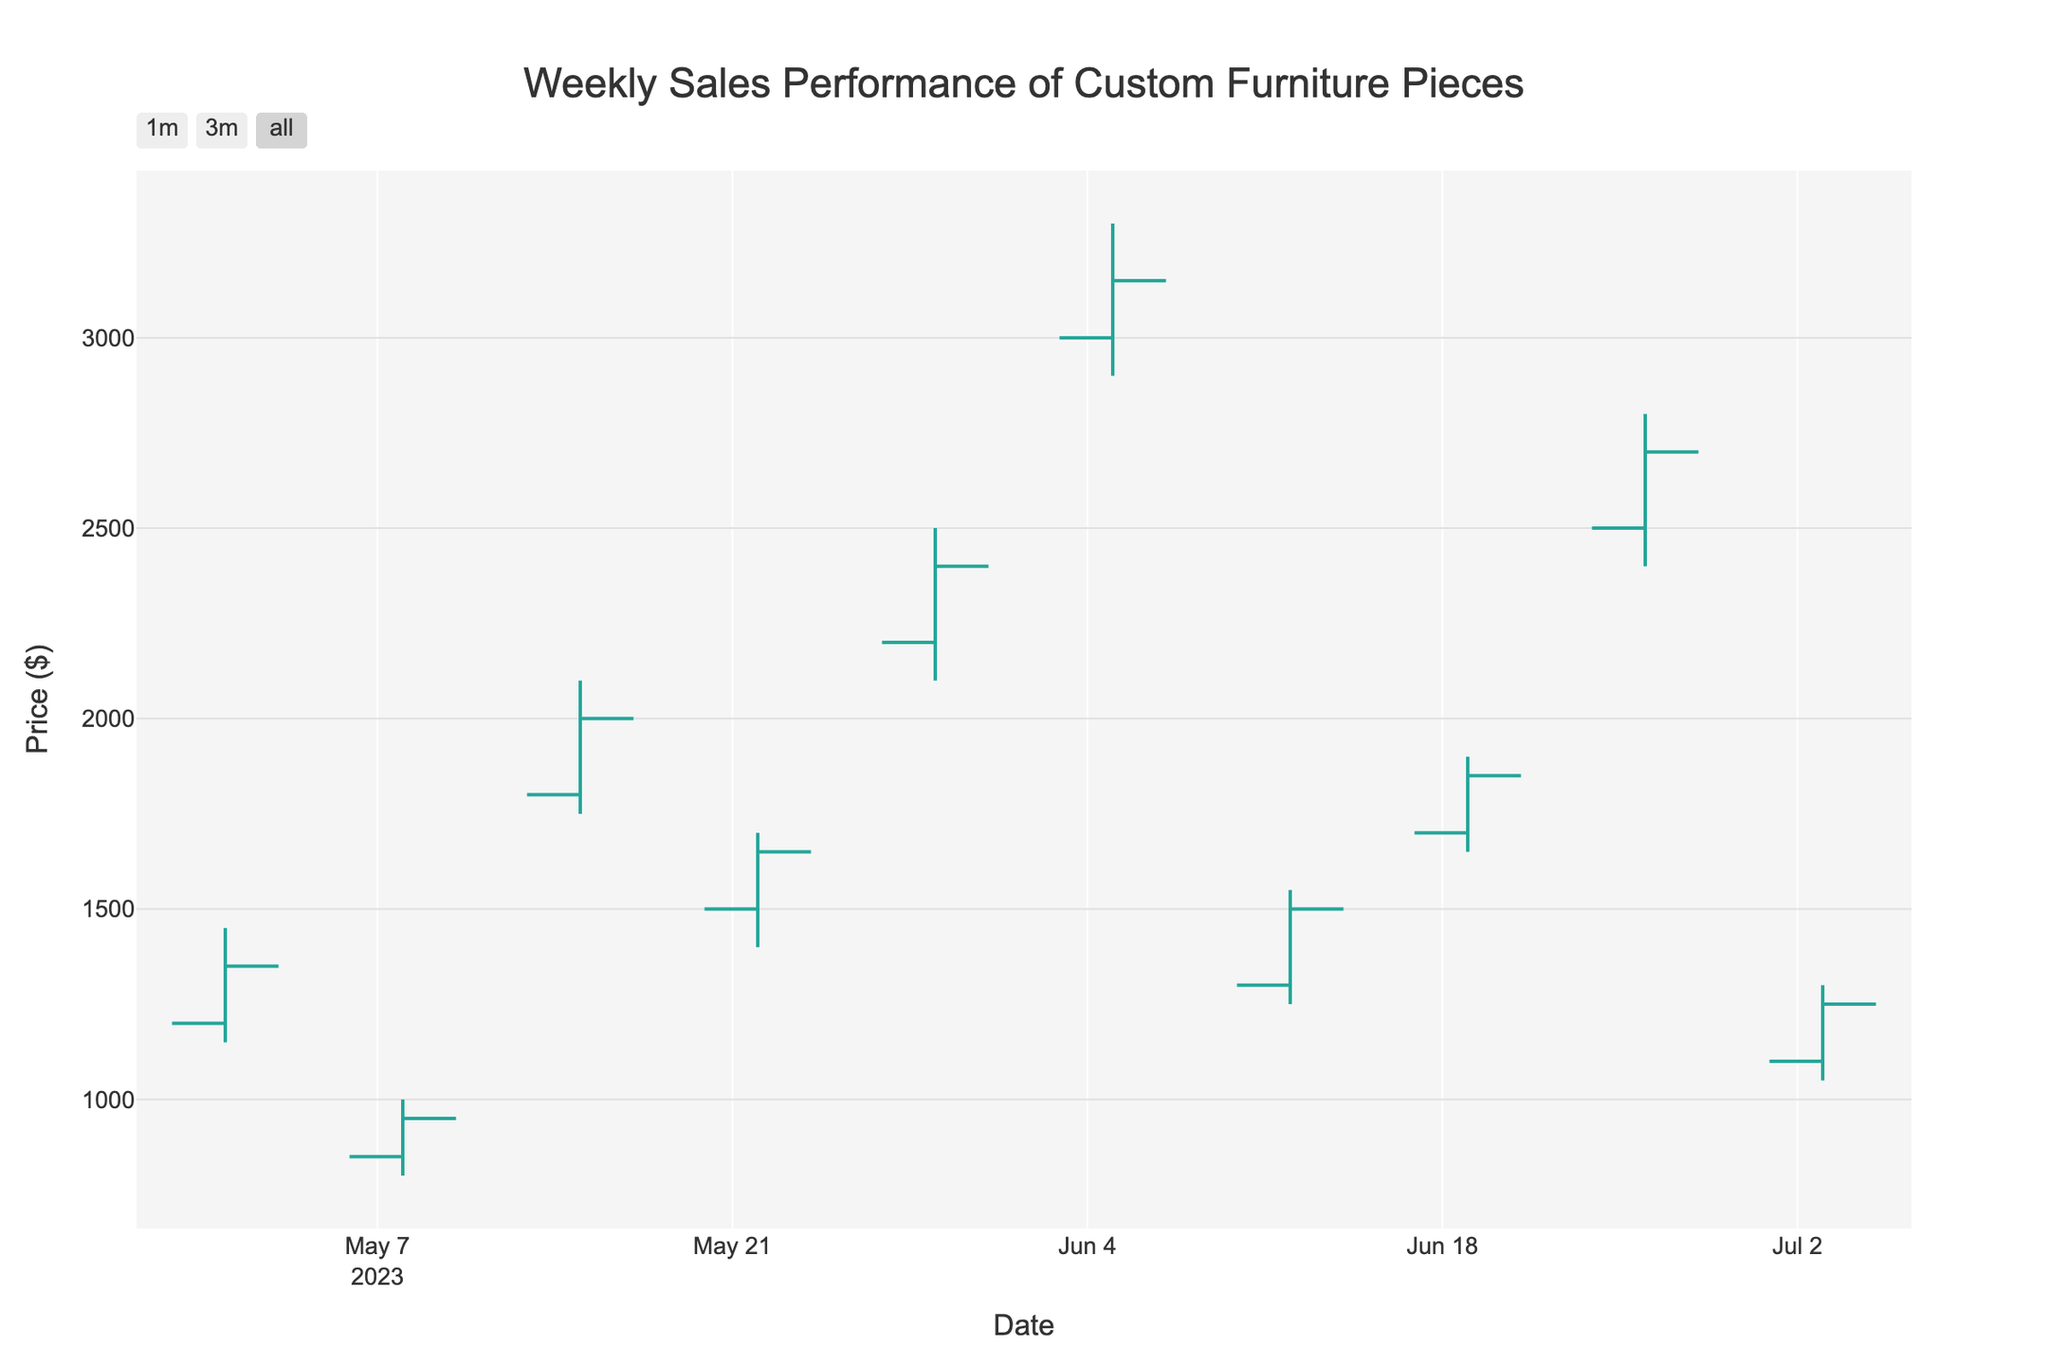what is the title of the chart? The title of the chart is located at the top center of the figure. According to the code, it reads "Weekly Sales Performance of Custom Furniture Pieces".
Answer: Weekly Sales Performance of Custom Furniture Pieces What is the highest price recorded, and which piece did it correspond to? The highest price is represented by the highest point in the 'High' column of the OHLC chart. According to the data provided, the highest price recorded is $3300, and it corresponds to the "French Provincial Dining Set" for the week of 2023-06-05.
Answer: $3300, French Provincial Dining Set How did the Mexican Talavera Tile Table's closing price compare to its opening price? To compare the opening price and closing price for the Mexican Talavera Tile Table, look at the 'Open' and 'Close' values for the week of 2023-07-03. The opening price was $1100 and the closing price was $1250. Since $1250 is greater than $1100, the closing price is higher.
Answer: The closing price is higher Which piece saw the greatest increase in price from its low to high point within a single week, and what was the increase? To find the greatest increase within a single week, subtract the 'Low' value from the 'High' value for each piece and compare. The greatest increase is found by calculating: For "Indian Brass-inlaid Armoire" (2500-2100=400), which is the highest among all pieces.
Answer: Indian Brass-inlaid Armoire, $400 Between May 1st and July 3rd, which piece had the lowest opening price, and how much was it? Compare the 'Open' prices for all pieces within the date range provided. The lowest opening price is $850, which corresponds to the "Moroccan Carved Coffee Table" for the week of 2023-05-08.
Answer: Moroccan Carved Coffee Table, $850 What was the average closing price of all the custom furniture pieces? To find the average closing price, sum the 'Close' values and then divide by the number of pieces (10). Sum: 1350+950+2000+1650+2400+3150+1500+1850+2700+1250 = 17800. Average: 17800 / 10 = 1780.
Answer: $1780 Which piece had the smallest range between its high and low prices? Calculate the range (High - Low) for each piece and identify the smallest one. For the "Chinese Lacquered Console," the range is (1900-1650 = 250), which is the smallest range.
Answer: Chinese Lacquered Console What were the opening and closing prices for the Scandinavian Minimalist Desk? Locate the "Scandinavian Minimalist Desk" from the data, corresponding to the week of 2023-05-22. The opening price was $1500, and the closing price was $1650.
Answer: Opening: $1500, Closing: $1650 Which piece's closing price was the highest among the last three weeks of data? Extract and compare the closing prices for the last three weeks (2023-06-19, 2023-06-26, and 2023-07-03). For the Chinese Lacquered Console (1850), Italian Renaissance Bed Frame (2700), and Mexican Talavera Tile Table (1250). The highest closing price is $2700 for the "Italian Renaissance Bed Frame".
Answer: Italian Renaissance Bed Frame 